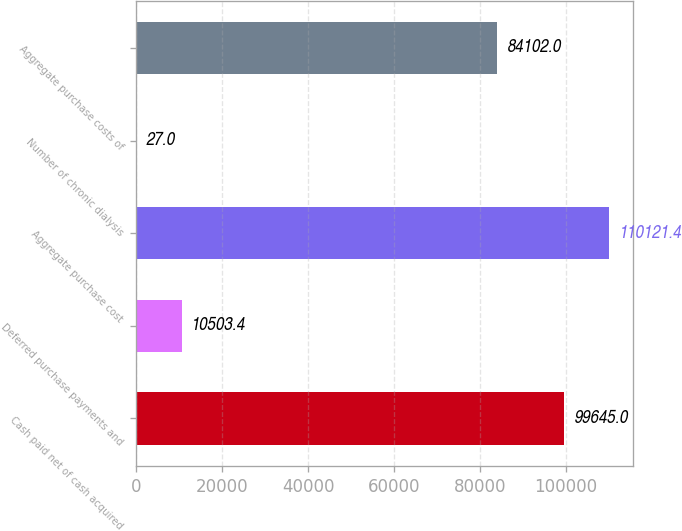<chart> <loc_0><loc_0><loc_500><loc_500><bar_chart><fcel>Cash paid net of cash acquired<fcel>Deferred purchase payments and<fcel>Aggregate purchase cost<fcel>Number of chronic dialysis<fcel>Aggregate purchase costs of<nl><fcel>99645<fcel>10503.4<fcel>110121<fcel>27<fcel>84102<nl></chart> 